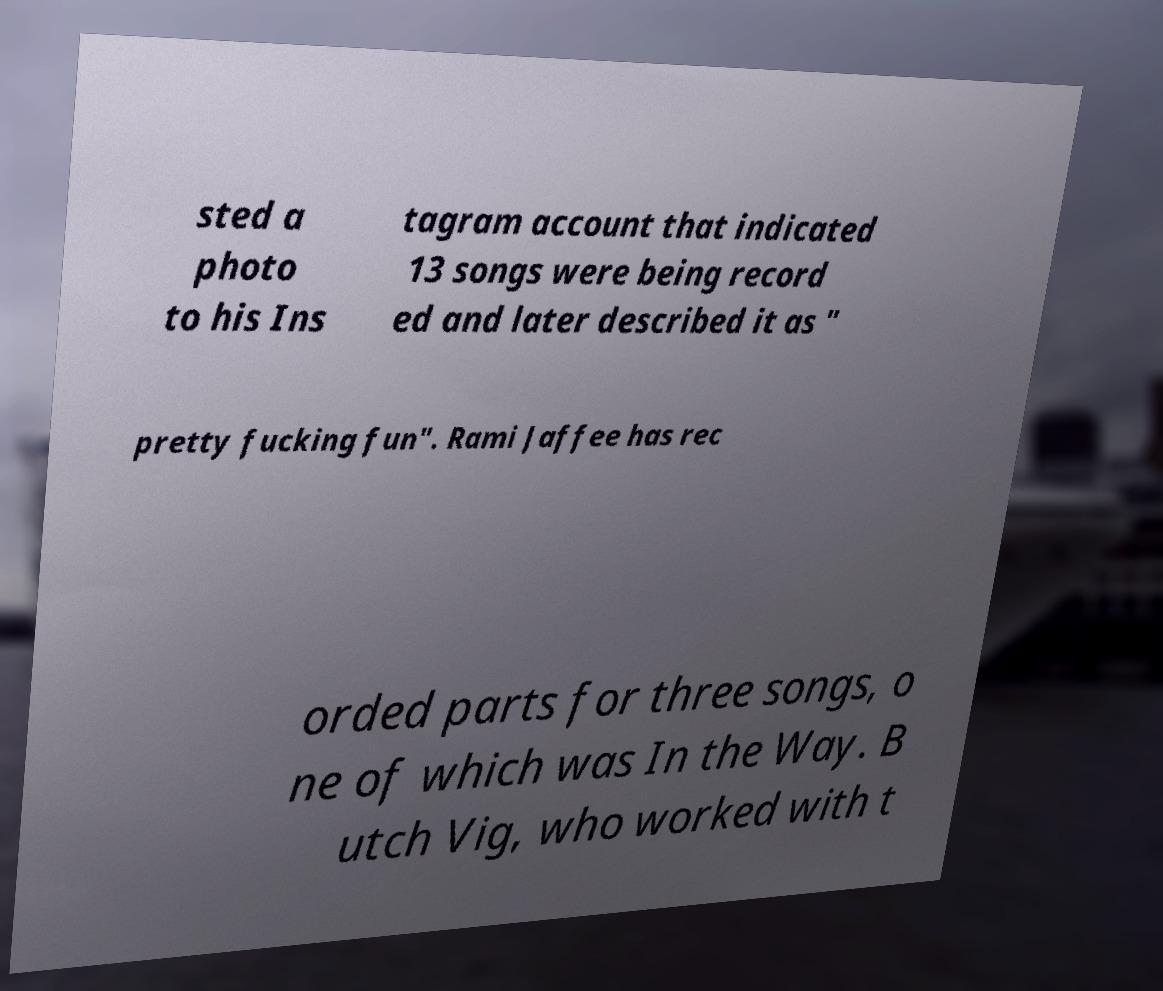I need the written content from this picture converted into text. Can you do that? sted a photo to his Ins tagram account that indicated 13 songs were being record ed and later described it as " pretty fucking fun". Rami Jaffee has rec orded parts for three songs, o ne of which was In the Way. B utch Vig, who worked with t 